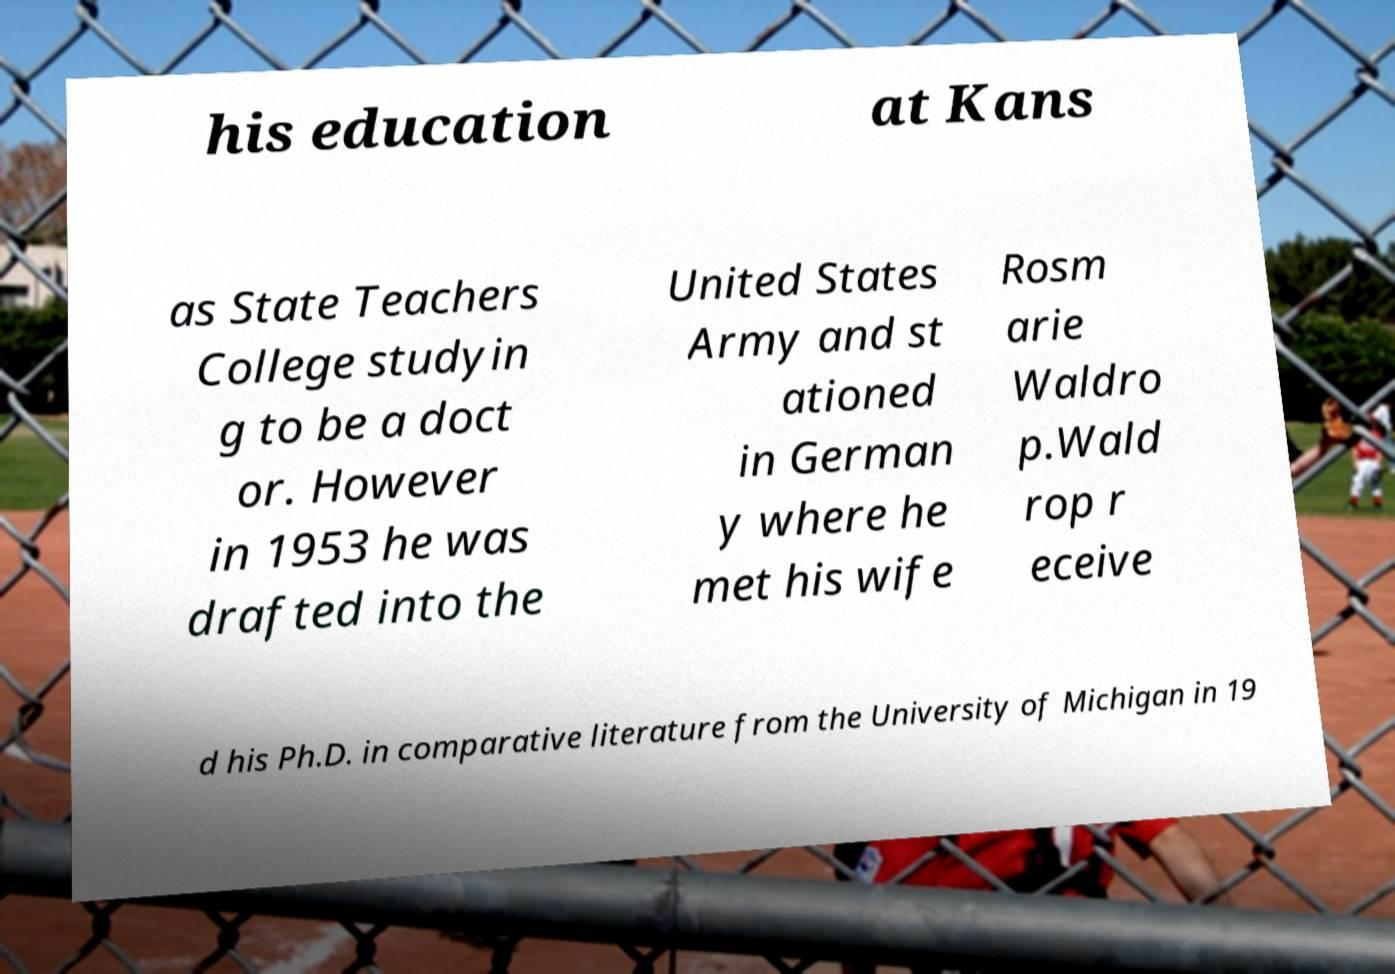I need the written content from this picture converted into text. Can you do that? his education at Kans as State Teachers College studyin g to be a doct or. However in 1953 he was drafted into the United States Army and st ationed in German y where he met his wife Rosm arie Waldro p.Wald rop r eceive d his Ph.D. in comparative literature from the University of Michigan in 19 